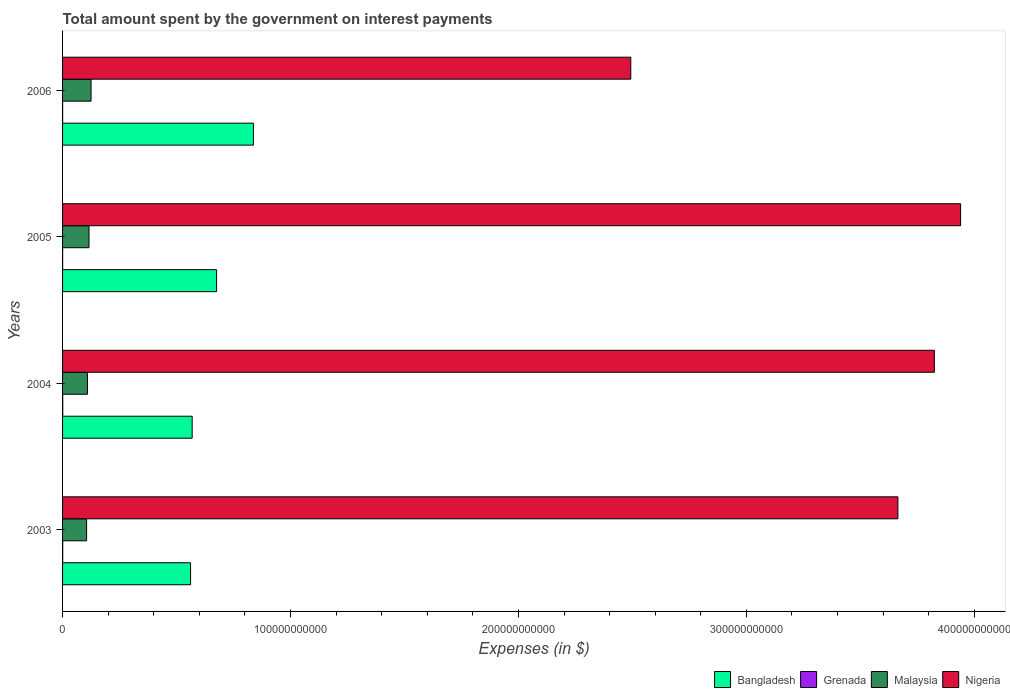How many different coloured bars are there?
Provide a succinct answer. 4. Are the number of bars per tick equal to the number of legend labels?
Offer a terse response. Yes. What is the label of the 4th group of bars from the top?
Offer a terse response. 2003. What is the amount spent on interest payments by the government in Nigeria in 2006?
Keep it short and to the point. 2.49e+11. Across all years, what is the maximum amount spent on interest payments by the government in Nigeria?
Offer a very short reply. 3.94e+11. Across all years, what is the minimum amount spent on interest payments by the government in Nigeria?
Your answer should be very brief. 2.49e+11. In which year was the amount spent on interest payments by the government in Bangladesh minimum?
Your answer should be very brief. 2003. What is the total amount spent on interest payments by the government in Grenada in the graph?
Ensure brevity in your answer.  1.92e+08. What is the difference between the amount spent on interest payments by the government in Malaysia in 2005 and that in 2006?
Your answer should be very brief. -8.91e+08. What is the difference between the amount spent on interest payments by the government in Bangladesh in 2006 and the amount spent on interest payments by the government in Nigeria in 2005?
Make the answer very short. -3.10e+11. What is the average amount spent on interest payments by the government in Malaysia per year?
Make the answer very short. 1.14e+1. In the year 2006, what is the difference between the amount spent on interest payments by the government in Grenada and amount spent on interest payments by the government in Nigeria?
Ensure brevity in your answer.  -2.49e+11. What is the ratio of the amount spent on interest payments by the government in Malaysia in 2005 to that in 2006?
Provide a short and direct response. 0.93. Is the amount spent on interest payments by the government in Bangladesh in 2003 less than that in 2006?
Provide a succinct answer. Yes. What is the difference between the highest and the second highest amount spent on interest payments by the government in Grenada?
Your answer should be very brief. 8.70e+06. What is the difference between the highest and the lowest amount spent on interest payments by the government in Malaysia?
Make the answer very short. 1.95e+09. In how many years, is the amount spent on interest payments by the government in Bangladesh greater than the average amount spent on interest payments by the government in Bangladesh taken over all years?
Provide a short and direct response. 2. What does the 1st bar from the top in 2005 represents?
Offer a very short reply. Nigeria. What does the 1st bar from the bottom in 2006 represents?
Provide a succinct answer. Bangladesh. How many years are there in the graph?
Make the answer very short. 4. What is the difference between two consecutive major ticks on the X-axis?
Give a very brief answer. 1.00e+11. Where does the legend appear in the graph?
Offer a terse response. Bottom right. How are the legend labels stacked?
Provide a short and direct response. Horizontal. What is the title of the graph?
Ensure brevity in your answer.  Total amount spent by the government on interest payments. What is the label or title of the X-axis?
Your answer should be compact. Expenses (in $). What is the label or title of the Y-axis?
Make the answer very short. Years. What is the Expenses (in $) in Bangladesh in 2003?
Your answer should be very brief. 5.62e+1. What is the Expenses (in $) in Grenada in 2003?
Your answer should be very brief. 6.31e+07. What is the Expenses (in $) of Malaysia in 2003?
Make the answer very short. 1.05e+1. What is the Expenses (in $) in Nigeria in 2003?
Offer a terse response. 3.66e+11. What is the Expenses (in $) of Bangladesh in 2004?
Your response must be concise. 5.69e+1. What is the Expenses (in $) in Grenada in 2004?
Keep it short and to the point. 7.18e+07. What is the Expenses (in $) of Malaysia in 2004?
Give a very brief answer. 1.09e+1. What is the Expenses (in $) in Nigeria in 2004?
Your answer should be compact. 3.82e+11. What is the Expenses (in $) of Bangladesh in 2005?
Offer a very short reply. 6.76e+1. What is the Expenses (in $) of Grenada in 2005?
Provide a succinct answer. 2.78e+07. What is the Expenses (in $) of Malaysia in 2005?
Your answer should be compact. 1.16e+1. What is the Expenses (in $) in Nigeria in 2005?
Make the answer very short. 3.94e+11. What is the Expenses (in $) of Bangladesh in 2006?
Give a very brief answer. 8.37e+1. What is the Expenses (in $) of Grenada in 2006?
Offer a very short reply. 2.90e+07. What is the Expenses (in $) of Malaysia in 2006?
Offer a terse response. 1.25e+1. What is the Expenses (in $) in Nigeria in 2006?
Offer a terse response. 2.49e+11. Across all years, what is the maximum Expenses (in $) of Bangladesh?
Give a very brief answer. 8.37e+1. Across all years, what is the maximum Expenses (in $) in Grenada?
Give a very brief answer. 7.18e+07. Across all years, what is the maximum Expenses (in $) in Malaysia?
Your answer should be very brief. 1.25e+1. Across all years, what is the maximum Expenses (in $) in Nigeria?
Provide a short and direct response. 3.94e+11. Across all years, what is the minimum Expenses (in $) in Bangladesh?
Give a very brief answer. 5.62e+1. Across all years, what is the minimum Expenses (in $) in Grenada?
Offer a terse response. 2.78e+07. Across all years, what is the minimum Expenses (in $) in Malaysia?
Your response must be concise. 1.05e+1. Across all years, what is the minimum Expenses (in $) in Nigeria?
Give a very brief answer. 2.49e+11. What is the total Expenses (in $) of Bangladesh in the graph?
Make the answer very short. 2.64e+11. What is the total Expenses (in $) in Grenada in the graph?
Ensure brevity in your answer.  1.92e+08. What is the total Expenses (in $) of Malaysia in the graph?
Ensure brevity in your answer.  4.56e+1. What is the total Expenses (in $) in Nigeria in the graph?
Offer a terse response. 1.39e+12. What is the difference between the Expenses (in $) of Bangladesh in 2003 and that in 2004?
Give a very brief answer. -7.04e+08. What is the difference between the Expenses (in $) of Grenada in 2003 and that in 2004?
Provide a short and direct response. -8.70e+06. What is the difference between the Expenses (in $) in Malaysia in 2003 and that in 2004?
Provide a short and direct response. -3.73e+08. What is the difference between the Expenses (in $) in Nigeria in 2003 and that in 2004?
Make the answer very short. -1.60e+1. What is the difference between the Expenses (in $) of Bangladesh in 2003 and that in 2005?
Your response must be concise. -1.14e+1. What is the difference between the Expenses (in $) of Grenada in 2003 and that in 2005?
Provide a short and direct response. 3.53e+07. What is the difference between the Expenses (in $) of Malaysia in 2003 and that in 2005?
Keep it short and to the point. -1.06e+09. What is the difference between the Expenses (in $) of Nigeria in 2003 and that in 2005?
Give a very brief answer. -2.75e+1. What is the difference between the Expenses (in $) of Bangladesh in 2003 and that in 2006?
Offer a very short reply. -2.76e+1. What is the difference between the Expenses (in $) of Grenada in 2003 and that in 2006?
Your answer should be very brief. 3.41e+07. What is the difference between the Expenses (in $) in Malaysia in 2003 and that in 2006?
Your response must be concise. -1.95e+09. What is the difference between the Expenses (in $) of Nigeria in 2003 and that in 2006?
Your answer should be very brief. 1.17e+11. What is the difference between the Expenses (in $) in Bangladesh in 2004 and that in 2005?
Provide a succinct answer. -1.07e+1. What is the difference between the Expenses (in $) in Grenada in 2004 and that in 2005?
Your response must be concise. 4.40e+07. What is the difference between the Expenses (in $) in Malaysia in 2004 and that in 2005?
Your response must be concise. -6.85e+08. What is the difference between the Expenses (in $) of Nigeria in 2004 and that in 2005?
Provide a succinct answer. -1.15e+1. What is the difference between the Expenses (in $) of Bangladesh in 2004 and that in 2006?
Give a very brief answer. -2.69e+1. What is the difference between the Expenses (in $) of Grenada in 2004 and that in 2006?
Offer a very short reply. 4.28e+07. What is the difference between the Expenses (in $) in Malaysia in 2004 and that in 2006?
Ensure brevity in your answer.  -1.58e+09. What is the difference between the Expenses (in $) in Nigeria in 2004 and that in 2006?
Your response must be concise. 1.33e+11. What is the difference between the Expenses (in $) in Bangladesh in 2005 and that in 2006?
Your answer should be very brief. -1.62e+1. What is the difference between the Expenses (in $) in Grenada in 2005 and that in 2006?
Your answer should be very brief. -1.20e+06. What is the difference between the Expenses (in $) in Malaysia in 2005 and that in 2006?
Offer a very short reply. -8.91e+08. What is the difference between the Expenses (in $) in Nigeria in 2005 and that in 2006?
Offer a very short reply. 1.45e+11. What is the difference between the Expenses (in $) in Bangladesh in 2003 and the Expenses (in $) in Grenada in 2004?
Provide a short and direct response. 5.61e+1. What is the difference between the Expenses (in $) in Bangladesh in 2003 and the Expenses (in $) in Malaysia in 2004?
Provide a short and direct response. 4.52e+1. What is the difference between the Expenses (in $) of Bangladesh in 2003 and the Expenses (in $) of Nigeria in 2004?
Provide a succinct answer. -3.26e+11. What is the difference between the Expenses (in $) in Grenada in 2003 and the Expenses (in $) in Malaysia in 2004?
Ensure brevity in your answer.  -1.09e+1. What is the difference between the Expenses (in $) of Grenada in 2003 and the Expenses (in $) of Nigeria in 2004?
Your answer should be very brief. -3.82e+11. What is the difference between the Expenses (in $) of Malaysia in 2003 and the Expenses (in $) of Nigeria in 2004?
Make the answer very short. -3.72e+11. What is the difference between the Expenses (in $) in Bangladesh in 2003 and the Expenses (in $) in Grenada in 2005?
Your answer should be very brief. 5.61e+1. What is the difference between the Expenses (in $) in Bangladesh in 2003 and the Expenses (in $) in Malaysia in 2005?
Your answer should be very brief. 4.46e+1. What is the difference between the Expenses (in $) of Bangladesh in 2003 and the Expenses (in $) of Nigeria in 2005?
Keep it short and to the point. -3.38e+11. What is the difference between the Expenses (in $) of Grenada in 2003 and the Expenses (in $) of Malaysia in 2005?
Offer a very short reply. -1.15e+1. What is the difference between the Expenses (in $) of Grenada in 2003 and the Expenses (in $) of Nigeria in 2005?
Offer a very short reply. -3.94e+11. What is the difference between the Expenses (in $) of Malaysia in 2003 and the Expenses (in $) of Nigeria in 2005?
Offer a very short reply. -3.83e+11. What is the difference between the Expenses (in $) of Bangladesh in 2003 and the Expenses (in $) of Grenada in 2006?
Your answer should be very brief. 5.61e+1. What is the difference between the Expenses (in $) of Bangladesh in 2003 and the Expenses (in $) of Malaysia in 2006?
Offer a terse response. 4.37e+1. What is the difference between the Expenses (in $) of Bangladesh in 2003 and the Expenses (in $) of Nigeria in 2006?
Your answer should be very brief. -1.93e+11. What is the difference between the Expenses (in $) in Grenada in 2003 and the Expenses (in $) in Malaysia in 2006?
Your response must be concise. -1.24e+1. What is the difference between the Expenses (in $) of Grenada in 2003 and the Expenses (in $) of Nigeria in 2006?
Keep it short and to the point. -2.49e+11. What is the difference between the Expenses (in $) of Malaysia in 2003 and the Expenses (in $) of Nigeria in 2006?
Provide a short and direct response. -2.39e+11. What is the difference between the Expenses (in $) in Bangladesh in 2004 and the Expenses (in $) in Grenada in 2005?
Your response must be concise. 5.68e+1. What is the difference between the Expenses (in $) in Bangladesh in 2004 and the Expenses (in $) in Malaysia in 2005?
Keep it short and to the point. 4.53e+1. What is the difference between the Expenses (in $) of Bangladesh in 2004 and the Expenses (in $) of Nigeria in 2005?
Your answer should be very brief. -3.37e+11. What is the difference between the Expenses (in $) of Grenada in 2004 and the Expenses (in $) of Malaysia in 2005?
Offer a terse response. -1.15e+1. What is the difference between the Expenses (in $) in Grenada in 2004 and the Expenses (in $) in Nigeria in 2005?
Give a very brief answer. -3.94e+11. What is the difference between the Expenses (in $) in Malaysia in 2004 and the Expenses (in $) in Nigeria in 2005?
Provide a short and direct response. -3.83e+11. What is the difference between the Expenses (in $) in Bangladesh in 2004 and the Expenses (in $) in Grenada in 2006?
Ensure brevity in your answer.  5.68e+1. What is the difference between the Expenses (in $) in Bangladesh in 2004 and the Expenses (in $) in Malaysia in 2006?
Give a very brief answer. 4.44e+1. What is the difference between the Expenses (in $) of Bangladesh in 2004 and the Expenses (in $) of Nigeria in 2006?
Offer a very short reply. -1.92e+11. What is the difference between the Expenses (in $) in Grenada in 2004 and the Expenses (in $) in Malaysia in 2006?
Your answer should be compact. -1.24e+1. What is the difference between the Expenses (in $) in Grenada in 2004 and the Expenses (in $) in Nigeria in 2006?
Ensure brevity in your answer.  -2.49e+11. What is the difference between the Expenses (in $) of Malaysia in 2004 and the Expenses (in $) of Nigeria in 2006?
Provide a short and direct response. -2.38e+11. What is the difference between the Expenses (in $) of Bangladesh in 2005 and the Expenses (in $) of Grenada in 2006?
Your answer should be very brief. 6.75e+1. What is the difference between the Expenses (in $) of Bangladesh in 2005 and the Expenses (in $) of Malaysia in 2006?
Your response must be concise. 5.51e+1. What is the difference between the Expenses (in $) of Bangladesh in 2005 and the Expenses (in $) of Nigeria in 2006?
Provide a succinct answer. -1.82e+11. What is the difference between the Expenses (in $) of Grenada in 2005 and the Expenses (in $) of Malaysia in 2006?
Ensure brevity in your answer.  -1.25e+1. What is the difference between the Expenses (in $) of Grenada in 2005 and the Expenses (in $) of Nigeria in 2006?
Your answer should be very brief. -2.49e+11. What is the difference between the Expenses (in $) of Malaysia in 2005 and the Expenses (in $) of Nigeria in 2006?
Provide a short and direct response. -2.38e+11. What is the average Expenses (in $) of Bangladesh per year?
Make the answer very short. 6.61e+1. What is the average Expenses (in $) in Grenada per year?
Ensure brevity in your answer.  4.79e+07. What is the average Expenses (in $) in Malaysia per year?
Ensure brevity in your answer.  1.14e+1. What is the average Expenses (in $) of Nigeria per year?
Make the answer very short. 3.48e+11. In the year 2003, what is the difference between the Expenses (in $) of Bangladesh and Expenses (in $) of Grenada?
Make the answer very short. 5.61e+1. In the year 2003, what is the difference between the Expenses (in $) of Bangladesh and Expenses (in $) of Malaysia?
Offer a very short reply. 4.56e+1. In the year 2003, what is the difference between the Expenses (in $) in Bangladesh and Expenses (in $) in Nigeria?
Your answer should be very brief. -3.10e+11. In the year 2003, what is the difference between the Expenses (in $) of Grenada and Expenses (in $) of Malaysia?
Your response must be concise. -1.05e+1. In the year 2003, what is the difference between the Expenses (in $) in Grenada and Expenses (in $) in Nigeria?
Provide a short and direct response. -3.66e+11. In the year 2003, what is the difference between the Expenses (in $) of Malaysia and Expenses (in $) of Nigeria?
Make the answer very short. -3.56e+11. In the year 2004, what is the difference between the Expenses (in $) in Bangladesh and Expenses (in $) in Grenada?
Your answer should be very brief. 5.68e+1. In the year 2004, what is the difference between the Expenses (in $) in Bangladesh and Expenses (in $) in Malaysia?
Your answer should be very brief. 4.59e+1. In the year 2004, what is the difference between the Expenses (in $) of Bangladesh and Expenses (in $) of Nigeria?
Offer a terse response. -3.26e+11. In the year 2004, what is the difference between the Expenses (in $) of Grenada and Expenses (in $) of Malaysia?
Your response must be concise. -1.08e+1. In the year 2004, what is the difference between the Expenses (in $) in Grenada and Expenses (in $) in Nigeria?
Keep it short and to the point. -3.82e+11. In the year 2004, what is the difference between the Expenses (in $) in Malaysia and Expenses (in $) in Nigeria?
Keep it short and to the point. -3.72e+11. In the year 2005, what is the difference between the Expenses (in $) in Bangladesh and Expenses (in $) in Grenada?
Your response must be concise. 6.75e+1. In the year 2005, what is the difference between the Expenses (in $) of Bangladesh and Expenses (in $) of Malaysia?
Keep it short and to the point. 5.60e+1. In the year 2005, what is the difference between the Expenses (in $) in Bangladesh and Expenses (in $) in Nigeria?
Provide a succinct answer. -3.26e+11. In the year 2005, what is the difference between the Expenses (in $) in Grenada and Expenses (in $) in Malaysia?
Ensure brevity in your answer.  -1.16e+1. In the year 2005, what is the difference between the Expenses (in $) of Grenada and Expenses (in $) of Nigeria?
Offer a terse response. -3.94e+11. In the year 2005, what is the difference between the Expenses (in $) in Malaysia and Expenses (in $) in Nigeria?
Your answer should be compact. -3.82e+11. In the year 2006, what is the difference between the Expenses (in $) of Bangladesh and Expenses (in $) of Grenada?
Your answer should be very brief. 8.37e+1. In the year 2006, what is the difference between the Expenses (in $) in Bangladesh and Expenses (in $) in Malaysia?
Make the answer very short. 7.12e+1. In the year 2006, what is the difference between the Expenses (in $) of Bangladesh and Expenses (in $) of Nigeria?
Your response must be concise. -1.66e+11. In the year 2006, what is the difference between the Expenses (in $) in Grenada and Expenses (in $) in Malaysia?
Offer a terse response. -1.25e+1. In the year 2006, what is the difference between the Expenses (in $) in Grenada and Expenses (in $) in Nigeria?
Give a very brief answer. -2.49e+11. In the year 2006, what is the difference between the Expenses (in $) of Malaysia and Expenses (in $) of Nigeria?
Keep it short and to the point. -2.37e+11. What is the ratio of the Expenses (in $) in Bangladesh in 2003 to that in 2004?
Provide a succinct answer. 0.99. What is the ratio of the Expenses (in $) of Grenada in 2003 to that in 2004?
Ensure brevity in your answer.  0.88. What is the ratio of the Expenses (in $) in Malaysia in 2003 to that in 2004?
Provide a short and direct response. 0.97. What is the ratio of the Expenses (in $) of Nigeria in 2003 to that in 2004?
Give a very brief answer. 0.96. What is the ratio of the Expenses (in $) of Bangladesh in 2003 to that in 2005?
Offer a terse response. 0.83. What is the ratio of the Expenses (in $) in Grenada in 2003 to that in 2005?
Offer a very short reply. 2.27. What is the ratio of the Expenses (in $) of Malaysia in 2003 to that in 2005?
Ensure brevity in your answer.  0.91. What is the ratio of the Expenses (in $) in Nigeria in 2003 to that in 2005?
Your answer should be very brief. 0.93. What is the ratio of the Expenses (in $) of Bangladesh in 2003 to that in 2006?
Offer a terse response. 0.67. What is the ratio of the Expenses (in $) of Grenada in 2003 to that in 2006?
Provide a succinct answer. 2.18. What is the ratio of the Expenses (in $) of Malaysia in 2003 to that in 2006?
Give a very brief answer. 0.84. What is the ratio of the Expenses (in $) in Nigeria in 2003 to that in 2006?
Your answer should be very brief. 1.47. What is the ratio of the Expenses (in $) of Bangladesh in 2004 to that in 2005?
Your answer should be compact. 0.84. What is the ratio of the Expenses (in $) in Grenada in 2004 to that in 2005?
Your answer should be very brief. 2.58. What is the ratio of the Expenses (in $) in Malaysia in 2004 to that in 2005?
Make the answer very short. 0.94. What is the ratio of the Expenses (in $) in Nigeria in 2004 to that in 2005?
Your response must be concise. 0.97. What is the ratio of the Expenses (in $) in Bangladesh in 2004 to that in 2006?
Ensure brevity in your answer.  0.68. What is the ratio of the Expenses (in $) in Grenada in 2004 to that in 2006?
Ensure brevity in your answer.  2.48. What is the ratio of the Expenses (in $) in Malaysia in 2004 to that in 2006?
Make the answer very short. 0.87. What is the ratio of the Expenses (in $) in Nigeria in 2004 to that in 2006?
Offer a terse response. 1.53. What is the ratio of the Expenses (in $) in Bangladesh in 2005 to that in 2006?
Your answer should be compact. 0.81. What is the ratio of the Expenses (in $) of Grenada in 2005 to that in 2006?
Keep it short and to the point. 0.96. What is the ratio of the Expenses (in $) of Malaysia in 2005 to that in 2006?
Provide a short and direct response. 0.93. What is the ratio of the Expenses (in $) in Nigeria in 2005 to that in 2006?
Your response must be concise. 1.58. What is the difference between the highest and the second highest Expenses (in $) of Bangladesh?
Provide a short and direct response. 1.62e+1. What is the difference between the highest and the second highest Expenses (in $) in Grenada?
Provide a short and direct response. 8.70e+06. What is the difference between the highest and the second highest Expenses (in $) of Malaysia?
Offer a very short reply. 8.91e+08. What is the difference between the highest and the second highest Expenses (in $) in Nigeria?
Your response must be concise. 1.15e+1. What is the difference between the highest and the lowest Expenses (in $) in Bangladesh?
Your answer should be very brief. 2.76e+1. What is the difference between the highest and the lowest Expenses (in $) of Grenada?
Ensure brevity in your answer.  4.40e+07. What is the difference between the highest and the lowest Expenses (in $) of Malaysia?
Offer a very short reply. 1.95e+09. What is the difference between the highest and the lowest Expenses (in $) in Nigeria?
Make the answer very short. 1.45e+11. 